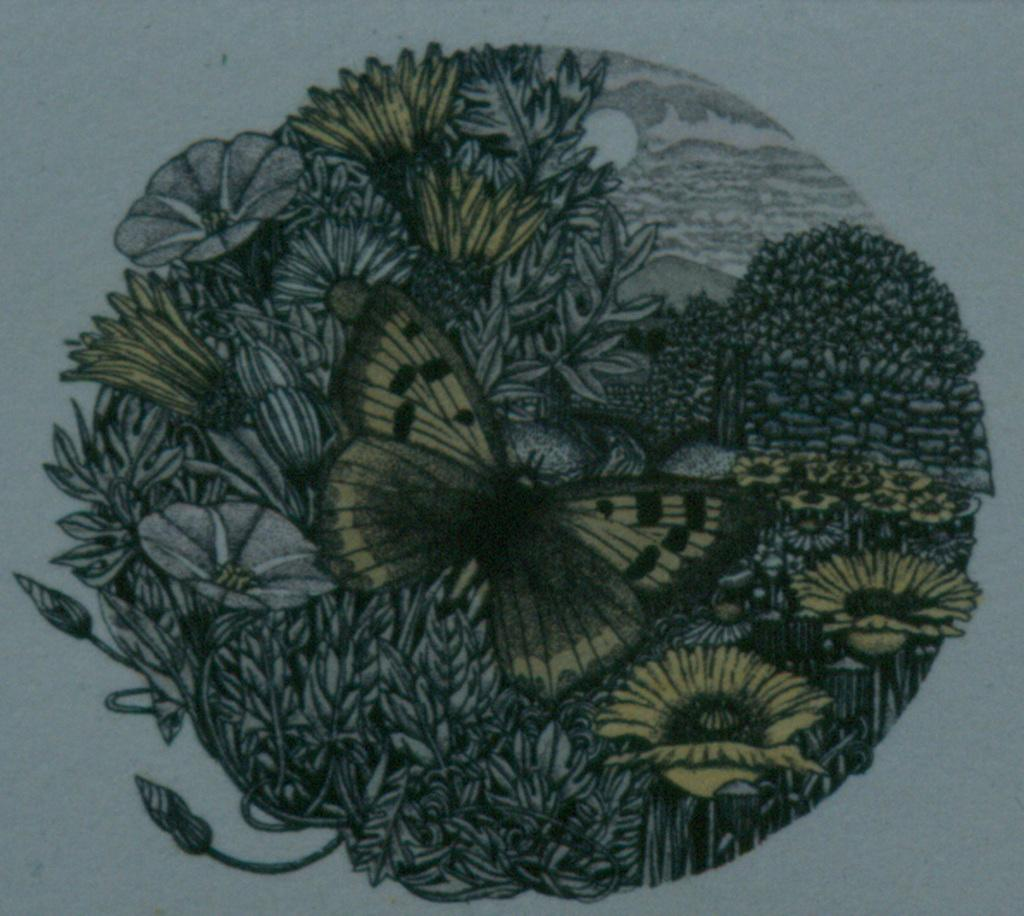What is the main subject of the painting in the image? The painting contains flowers, butterflies, and plants. What celestial body is visible in the painting? The sun is visible in the painting. What part of the natural environment is depicted in the painting? The sky is visible in the painting. What type of mist can be seen surrounding the yak in the painting? There is no mist or yak present in the painting; it features flowers, butterflies, plants, the sun, and the sky. What ingredients are used to make the stew in the painting? There is no stew present in the painting; it features flowers, butterflies, plants, the sun, and the sky. 